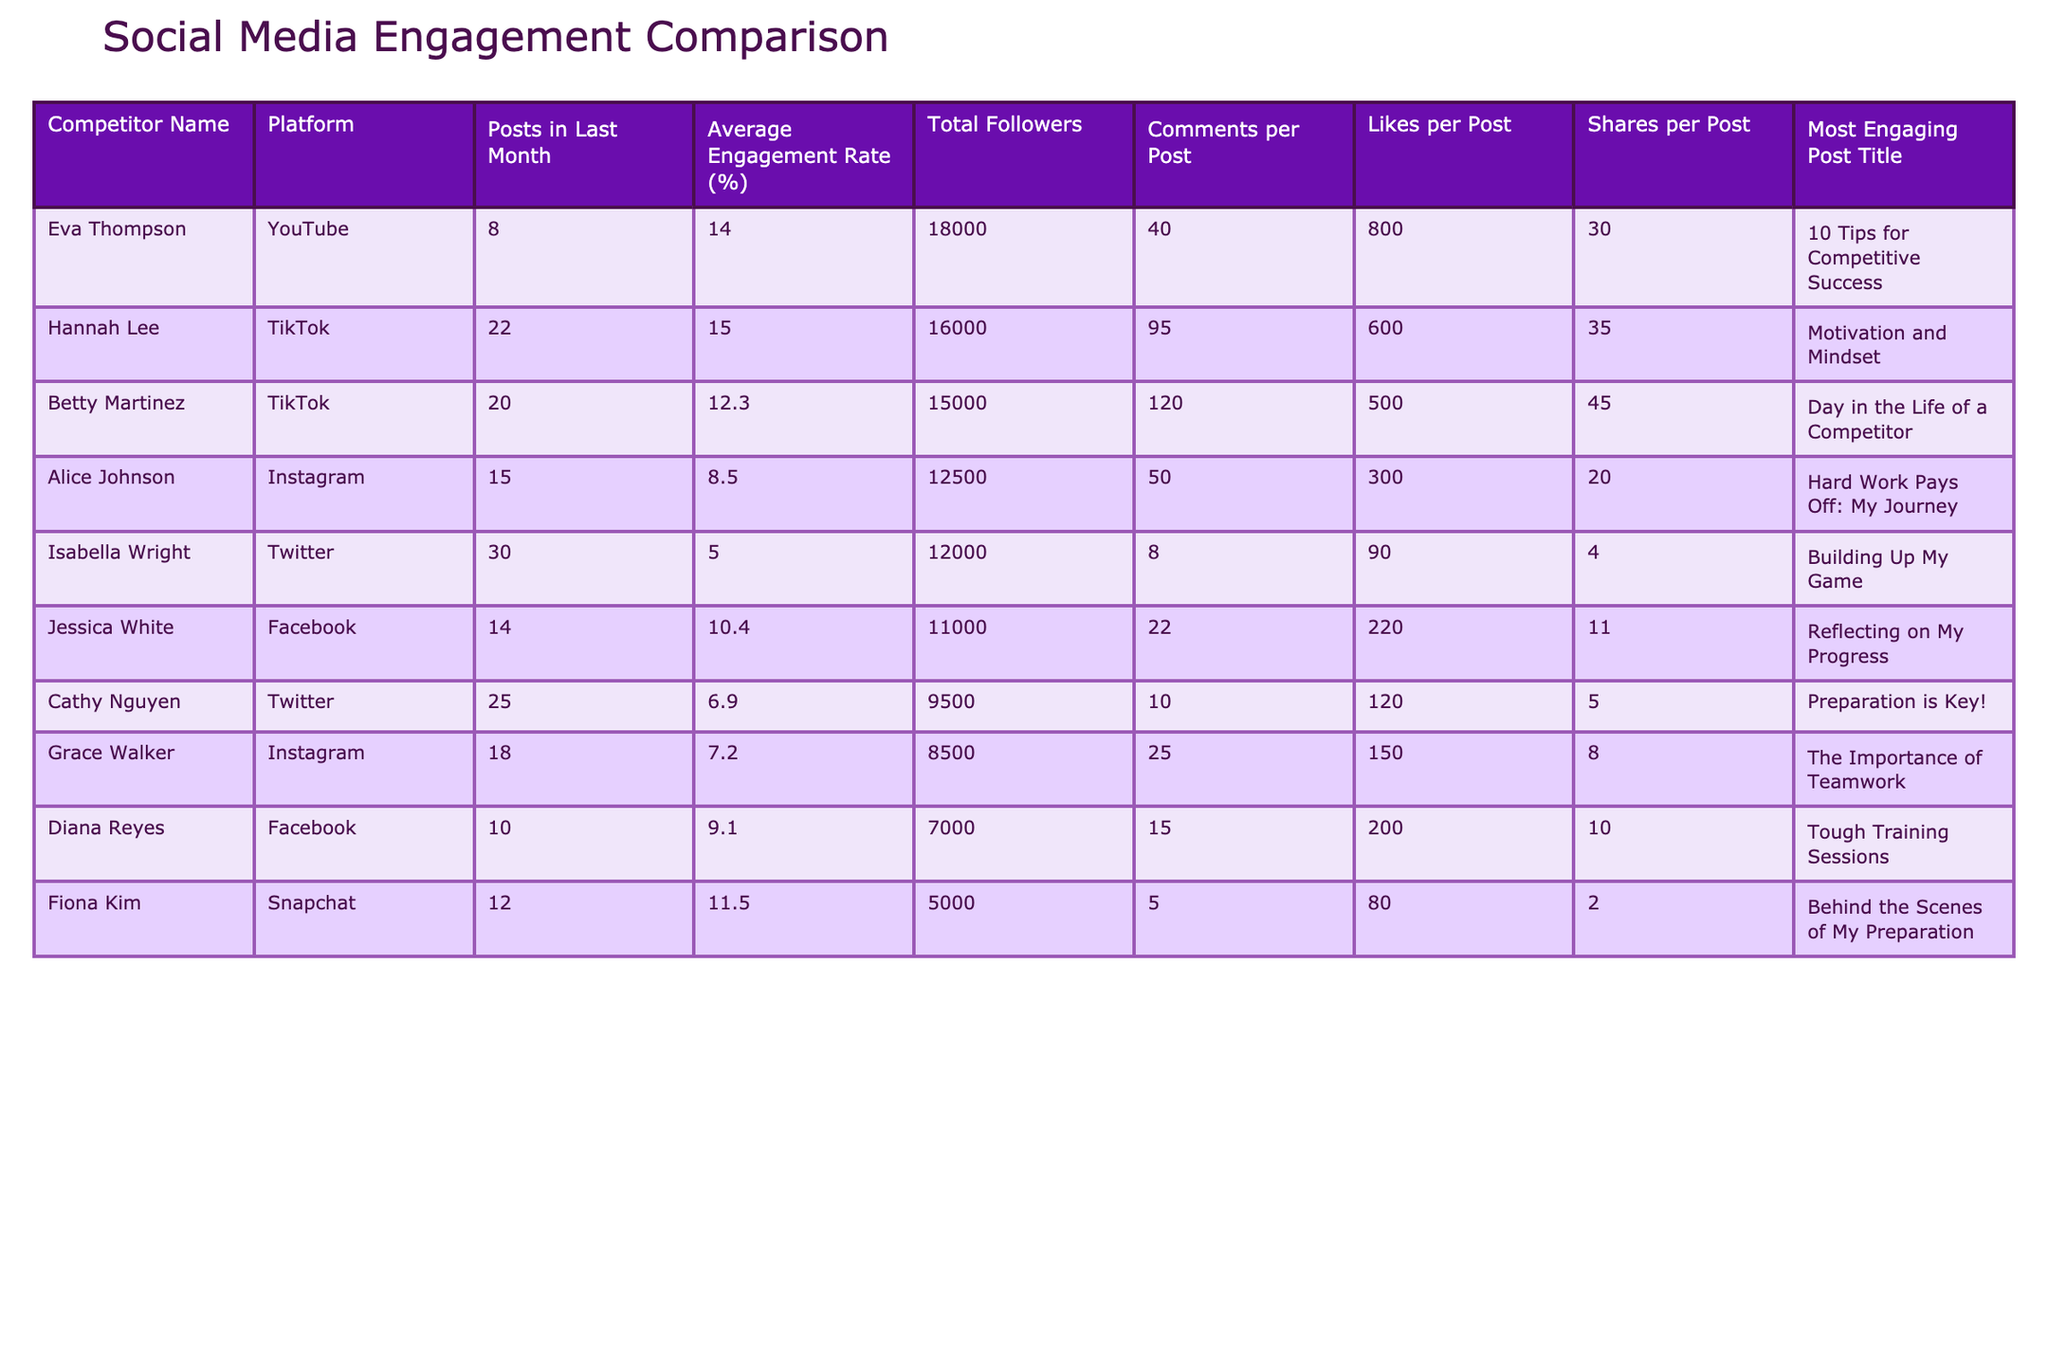What is the average engagement rate among all competitors? To calculate the average engagement rate, sum the engagement rates of all competitors: (8.5 + 12.3 + 6.9 + 9.1 + 14.0 + 11.5 + 7.2 + 15.0 + 5.0 + 10.4) = 84.9. Then, divide by the number of competitors (10): 84.9 / 10 = 8.49.
Answer: 8.49 Which competitor has the highest number of total followers? By examining the "Total Followers" column, Betty Martinez has 15000 followers, which is the highest among all competitors.
Answer: Betty Martinez How many posts did Hannah Lee make in the last month? The table shows that Hannah Lee made 22 posts last month, which can be directly found in the "Posts in Last Month" column.
Answer: 22 What is the total number of likes received by Jessica White across all her posts? Jessica White has an average of 220 likes per post and made 14 posts last month. To find the total likes, multiply: 220 likes/post * 14 posts = 3080 likes.
Answer: 3080 Is Eva Thompson's engagement rate higher than Alice Johnson's? Eva Thompson has an engagement rate of 14.0%, while Alice Johnson's rate is 8.5%. Since 14.0% > 8.5%, the statement is true.
Answer: Yes Which platform had the most posts among all competitors? To find the platform with the most posts, compare the "Posts in Last Month" for each competitor: Twitter (Cathy Nguyen) has 25 posts, which is the highest number.
Answer: Twitter What is the difference in average engagement rates between TikTok and Instagram competitors? The average engagement rate for TikTok (Betty Martinez + Hannah Lee) is (12.3 + 15.0) / 2 = 13.65%. For Instagram (Alice Johnson + Grace Walker), it is (8.5 + 7.2) / 2 = 7.85%. The difference is: 13.65% - 7.85% = 5.80%.
Answer: 5.80 Who had the most engaging post among the competitors? The competitor with the most engaging post can be found through the "Most Engaging Post Title" and their corresponding "Likes per Post" or "Shares per Post." Hannah Lee's post received 35 shares, the highest among all, indicating it was the most engaging.
Answer: Hannah Lee What is the total number of comments received by all competitors combined? To find the total comments, sum the "Comments per Post" for each competitor: 50 + 120 + 10 + 15 + 40 + 5 + 25 + 95 + 8 + 22 = 400.
Answer: 400 Does Diana Reyes have the lowest number of total followers among all competitors? Diana Reyes has 7000 total followers, which is compared against the followers of others. Indeed, this is the lowest count found in the table.
Answer: Yes 